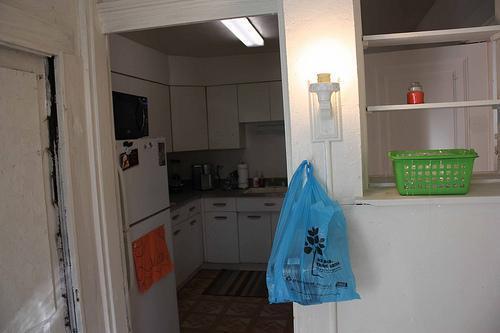How many microwaves are in the picture?
Give a very brief answer. 1. 